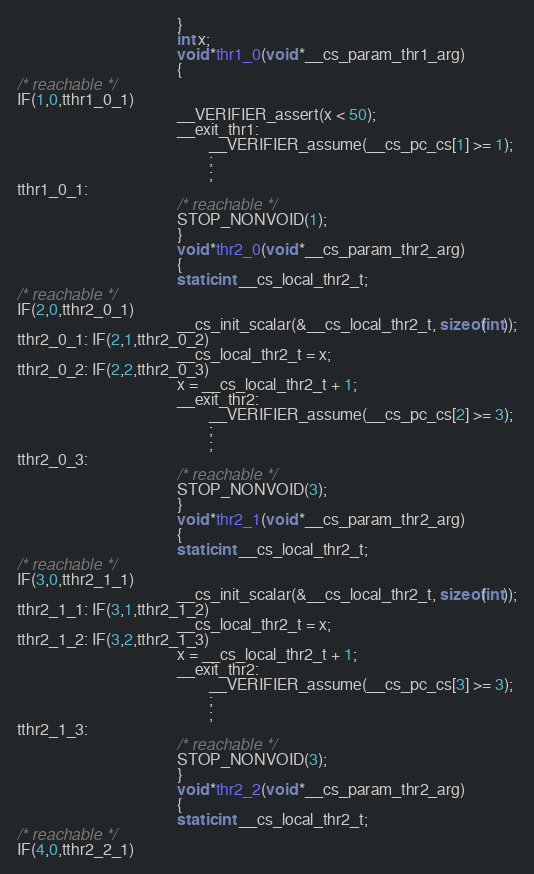Convert code to text. <code><loc_0><loc_0><loc_500><loc_500><_C_>                                        }
                                        int x;
                                        void *thr1_0(void *__cs_param_thr1_arg)
                                        {
/* reachable */
IF(1,0,tthr1_0_1)
                                        __VERIFIER_assert(x < 50);
                                        __exit_thr1:
                                        		__VERIFIER_assume(__cs_pc_cs[1] >= 1);
                                        		;
                                        		;
tthr1_0_1: 
                                        /* reachable */
                                        STOP_NONVOID(1);
                                        }
                                        void *thr2_0(void *__cs_param_thr2_arg)
                                        {
                                        static int __cs_local_thr2_t;
/* reachable */
IF(2,0,tthr2_0_1)
                                        __cs_init_scalar(&__cs_local_thr2_t, sizeof(int));
tthr2_0_1: IF(2,1,tthr2_0_2)
                                        __cs_local_thr2_t = x;
tthr2_0_2: IF(2,2,tthr2_0_3)
                                        x = __cs_local_thr2_t + 1;
                                        __exit_thr2:
                                        		__VERIFIER_assume(__cs_pc_cs[2] >= 3);
                                        		;
                                        		;
tthr2_0_3: 
                                        /* reachable */
                                        STOP_NONVOID(3);
                                        }
                                        void *thr2_1(void *__cs_param_thr2_arg)
                                        {
                                        static int __cs_local_thr2_t;
/* reachable */
IF(3,0,tthr2_1_1)
                                        __cs_init_scalar(&__cs_local_thr2_t, sizeof(int));
tthr2_1_1: IF(3,1,tthr2_1_2)
                                        __cs_local_thr2_t = x;
tthr2_1_2: IF(3,2,tthr2_1_3)
                                        x = __cs_local_thr2_t + 1;
                                        __exit_thr2:
                                        		__VERIFIER_assume(__cs_pc_cs[3] >= 3);
                                        		;
                                        		;
tthr2_1_3: 
                                        /* reachable */
                                        STOP_NONVOID(3);
                                        }
                                        void *thr2_2(void *__cs_param_thr2_arg)
                                        {
                                        static int __cs_local_thr2_t;
/* reachable */
IF(4,0,tthr2_2_1)</code> 